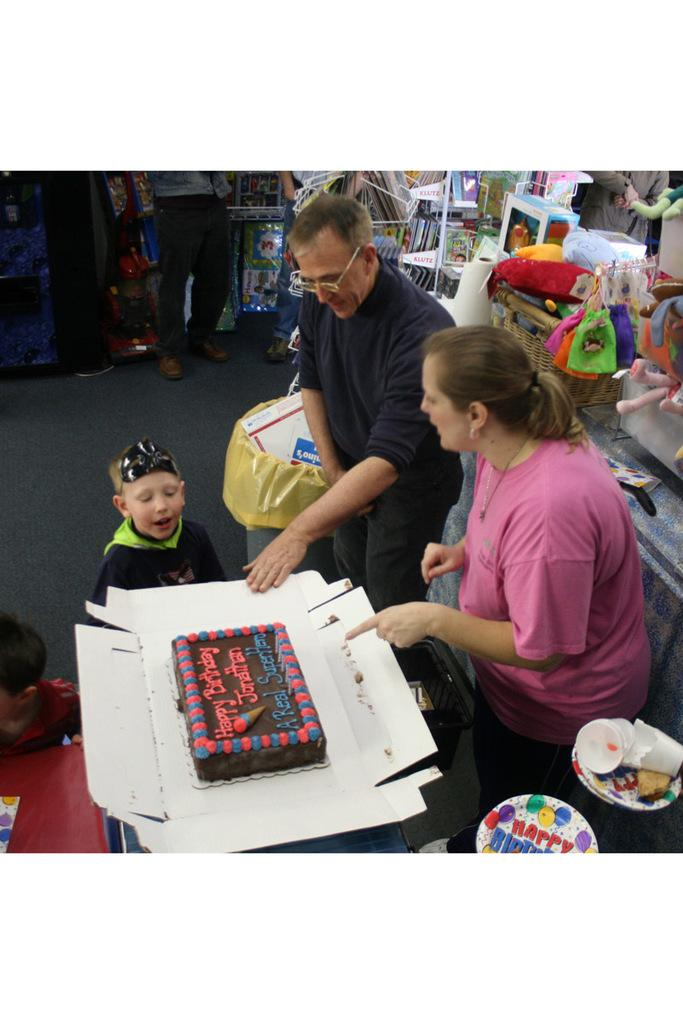How many people are present in the image? There are three people in the image: a man, a woman, and a boy. What objects can be seen in the image? There is a cake in the image. Can you describe the man in the image? The man is wearing glasses (specs). What else can be observed in the background of the image? There are more people in the background of the image. What type of operation is being performed on the cake in the image? There is no operation being performed on the cake in the image; it is simply present. How does the man maintain his balance while wearing the glasses in the image? The man's balance is not mentioned in the image, and wearing glasses does not affect balance. 